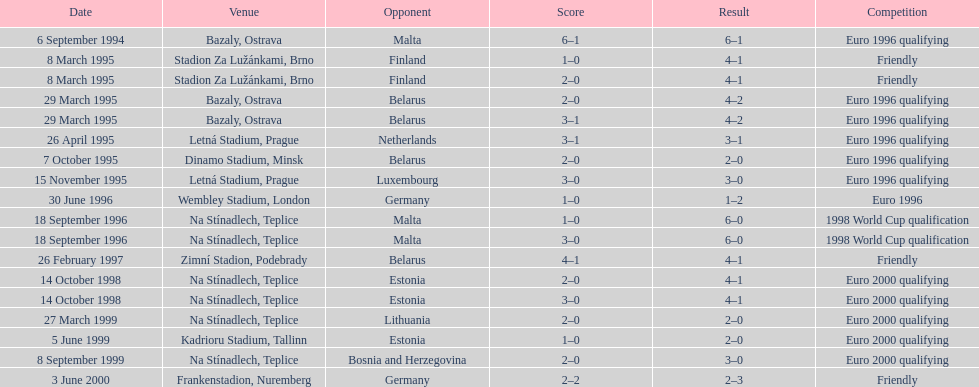In 1999, what was the total number of games that occurred? 3. 